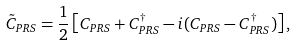Convert formula to latex. <formula><loc_0><loc_0><loc_500><loc_500>\tilde { C } _ { P R S } = \frac { 1 } { 2 } \left [ C _ { P R S } + C _ { P R S } ^ { \dagger } - i ( C _ { P R S } - C _ { P R S } ^ { \dagger } ) \right ] ,</formula> 